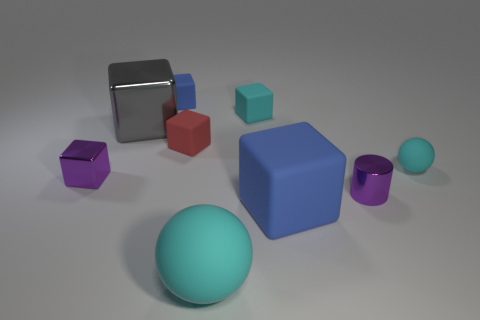Subtract all red cubes. How many cubes are left? 5 Subtract 3 cubes. How many cubes are left? 3 Subtract all blue rubber cubes. How many cubes are left? 4 Subtract all gray blocks. Subtract all gray balls. How many blocks are left? 5 Add 1 tiny gray balls. How many objects exist? 10 Subtract all spheres. How many objects are left? 7 Add 4 large gray metallic blocks. How many large gray metallic blocks exist? 5 Subtract 0 gray balls. How many objects are left? 9 Subtract all small purple metal cubes. Subtract all big gray cubes. How many objects are left? 7 Add 4 red blocks. How many red blocks are left? 5 